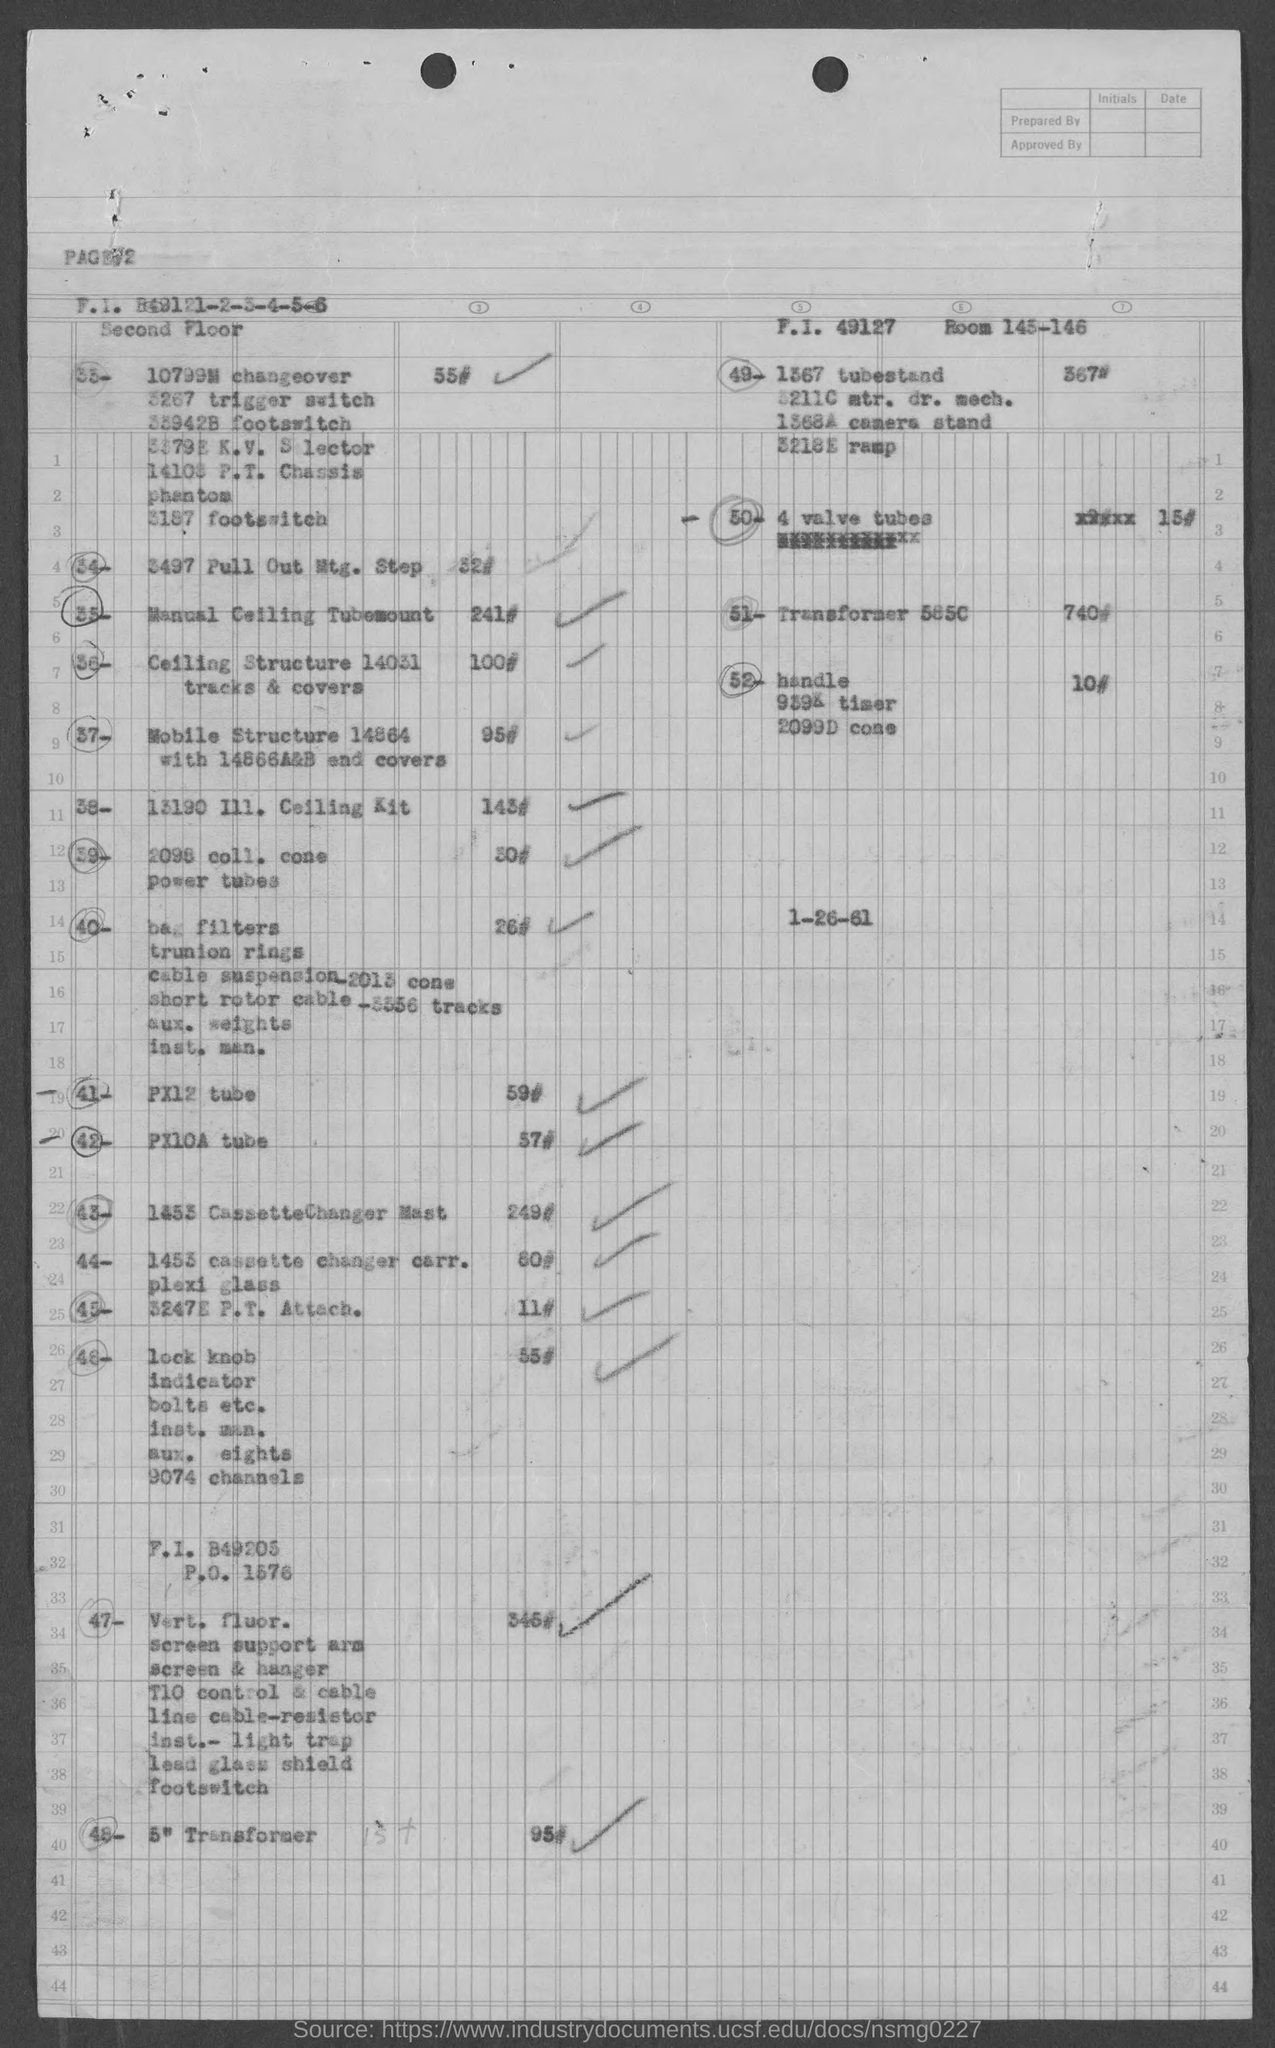Indicate a few pertinent items in this graphic. The room numbers in the top right corner are 145 and 146. 